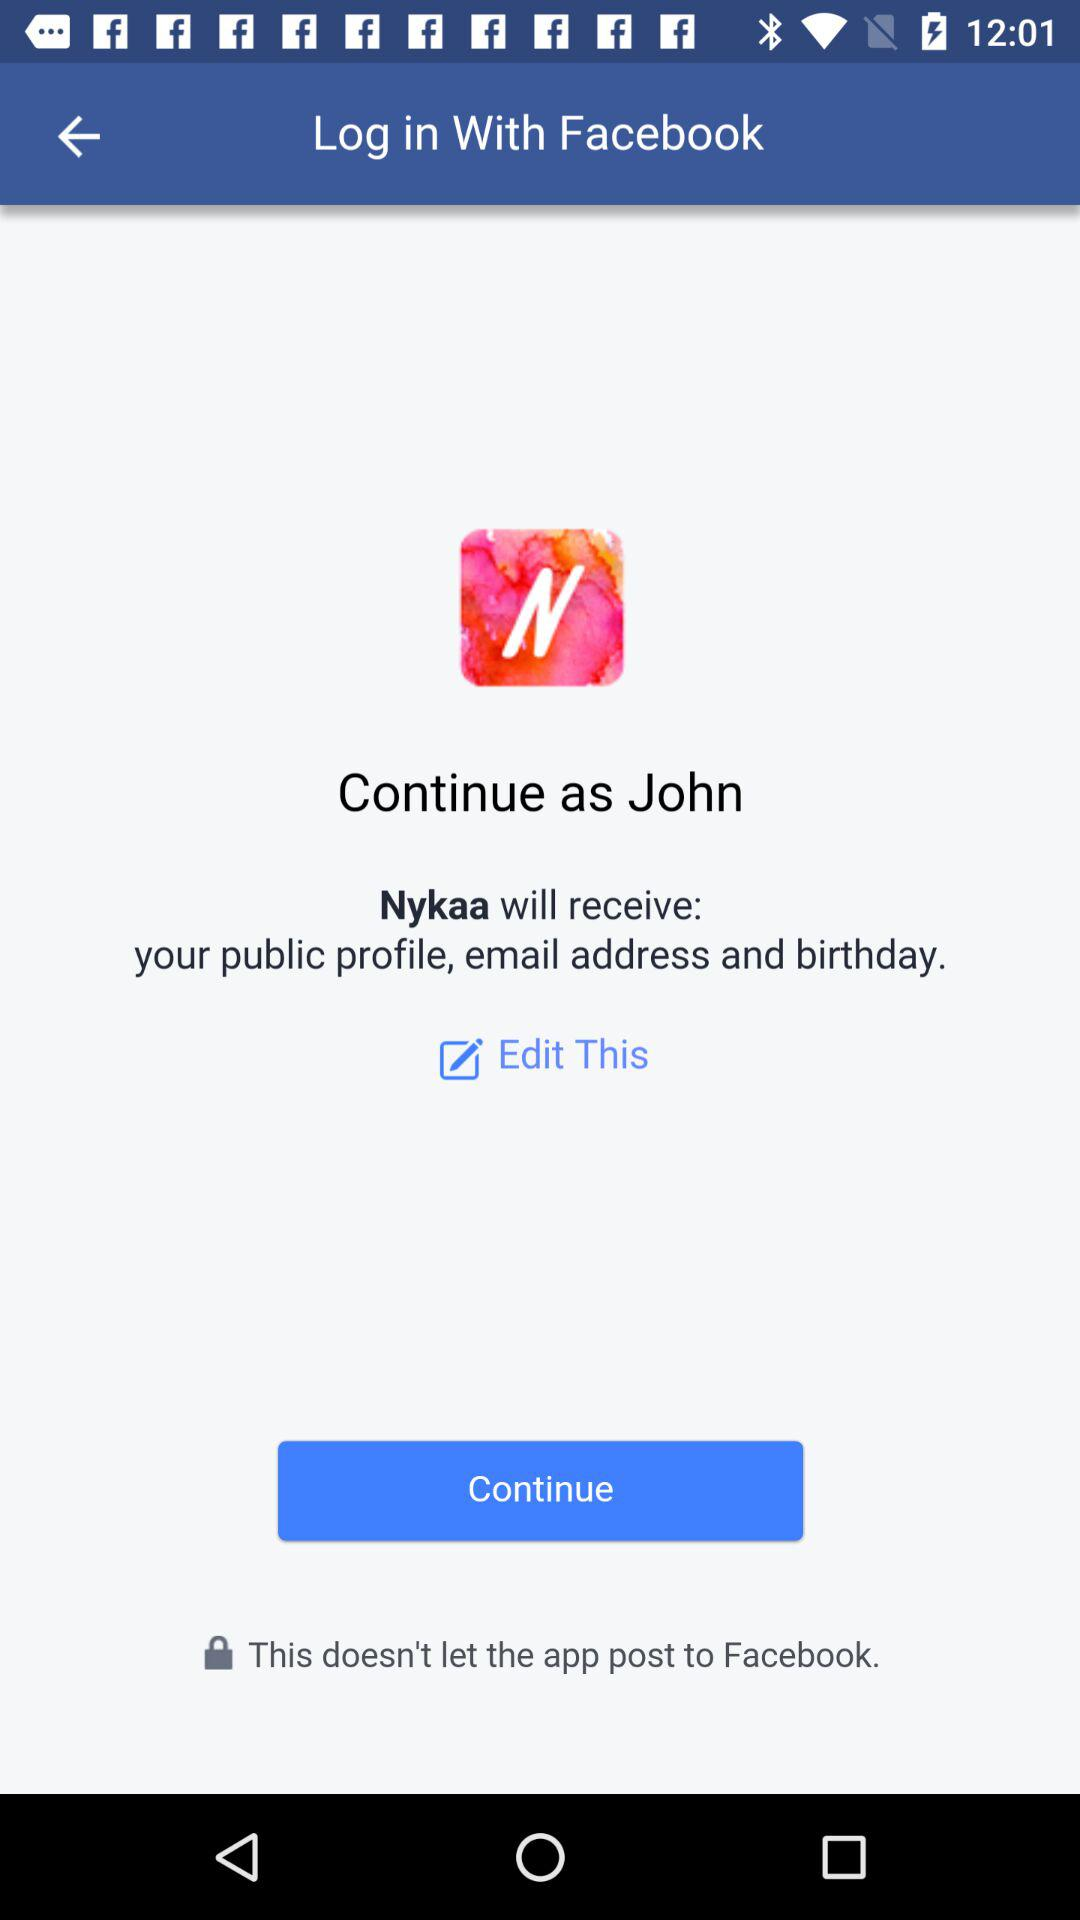What is the profile name? The profile name is John. 